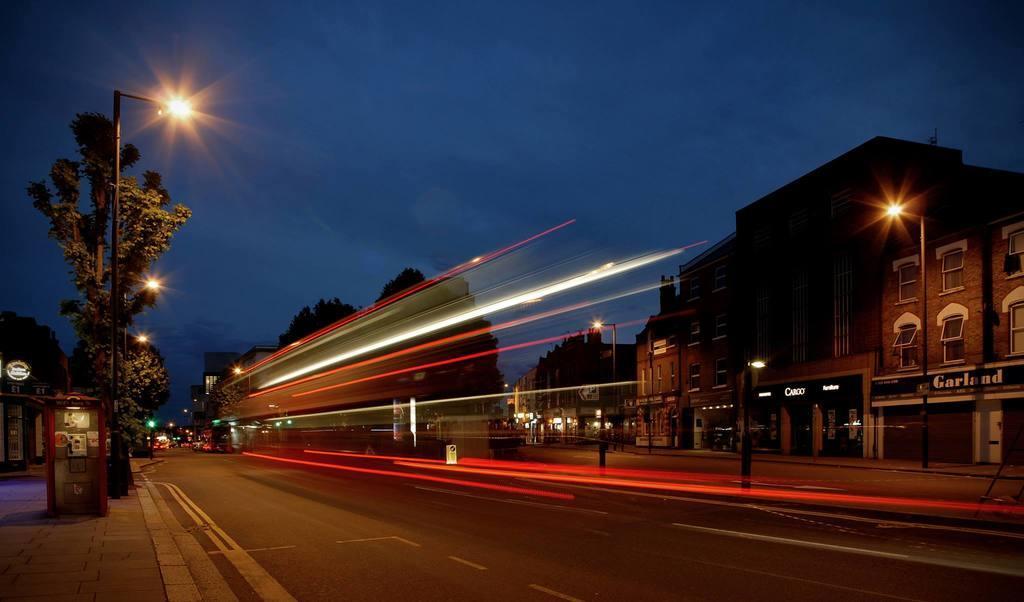Could you give a brief overview of what you see in this image? In this image there are buildings, road, trees, name boards, light boards, poles, lights, and in the background there is sky. 